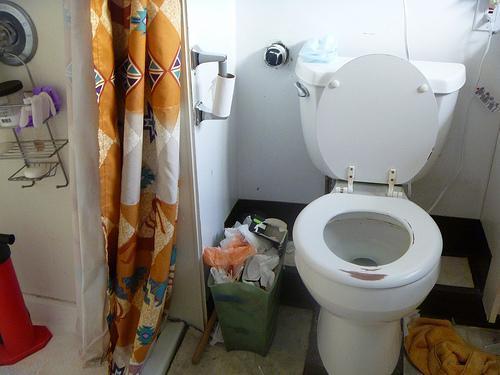How many toilets are pictured?
Give a very brief answer. 1. 